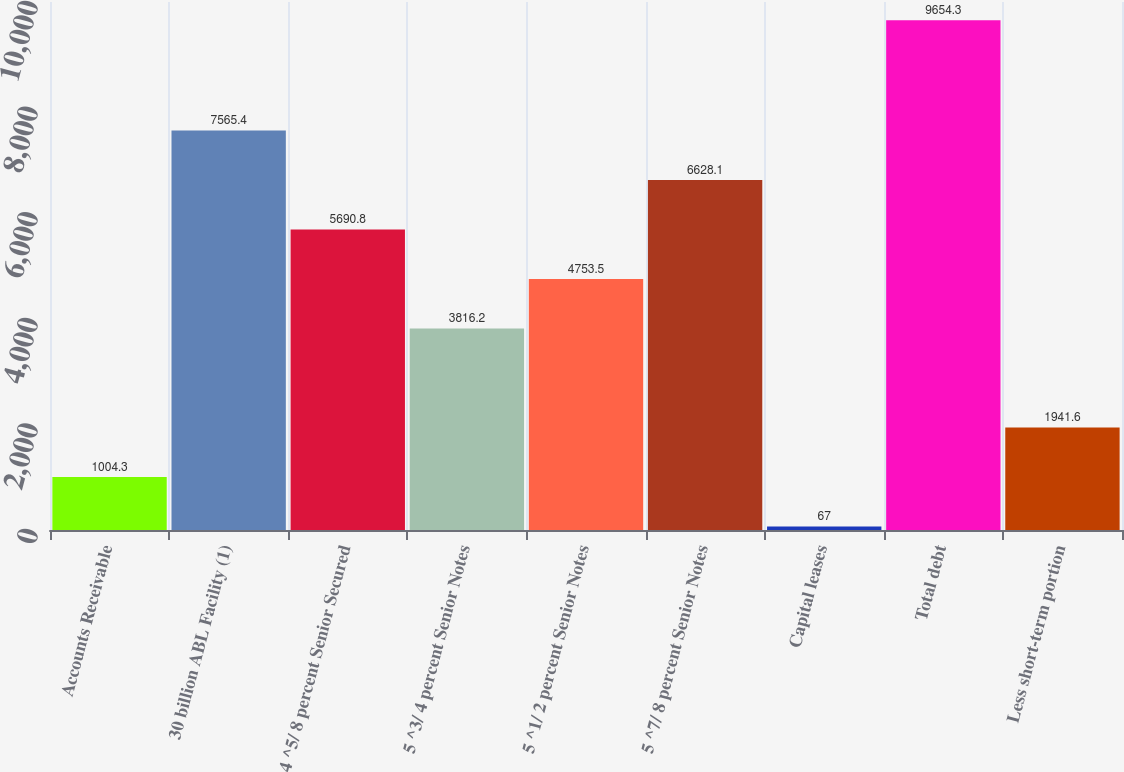Convert chart to OTSL. <chart><loc_0><loc_0><loc_500><loc_500><bar_chart><fcel>Accounts Receivable<fcel>30 billion ABL Facility (1)<fcel>4 ^5/ 8 percent Senior Secured<fcel>5 ^3/ 4 percent Senior Notes<fcel>5 ^1/ 2 percent Senior Notes<fcel>5 ^7/ 8 percent Senior Notes<fcel>Capital leases<fcel>Total debt<fcel>Less short-term portion<nl><fcel>1004.3<fcel>7565.4<fcel>5690.8<fcel>3816.2<fcel>4753.5<fcel>6628.1<fcel>67<fcel>9654.3<fcel>1941.6<nl></chart> 